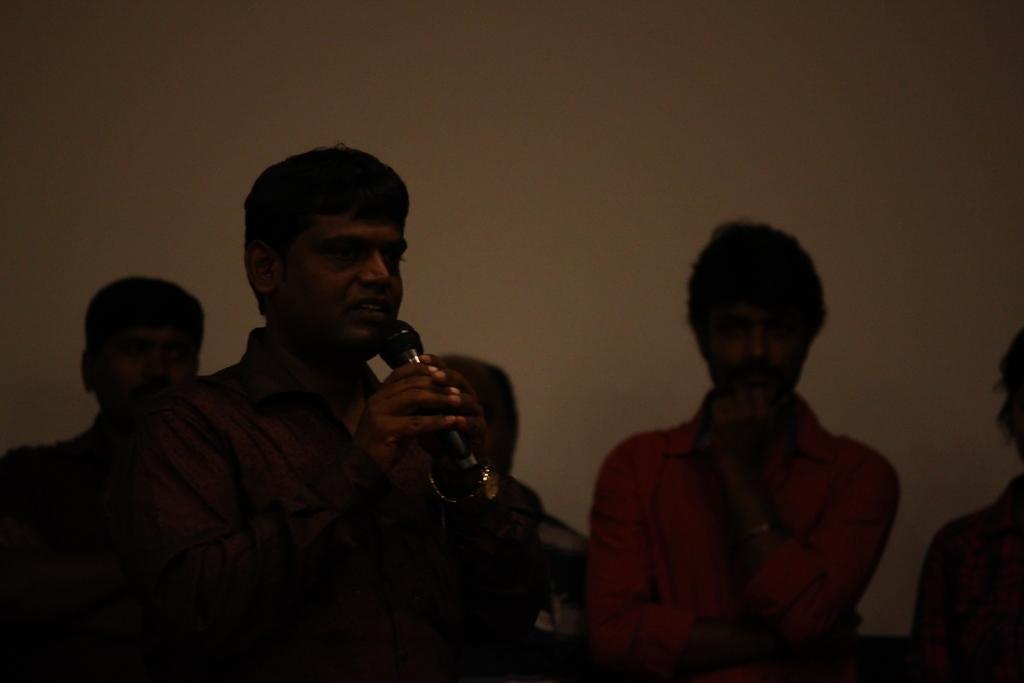How would you summarize this image in a sentence or two? A man is standing and speaking with a mic in his hand. There are few people behind him. 